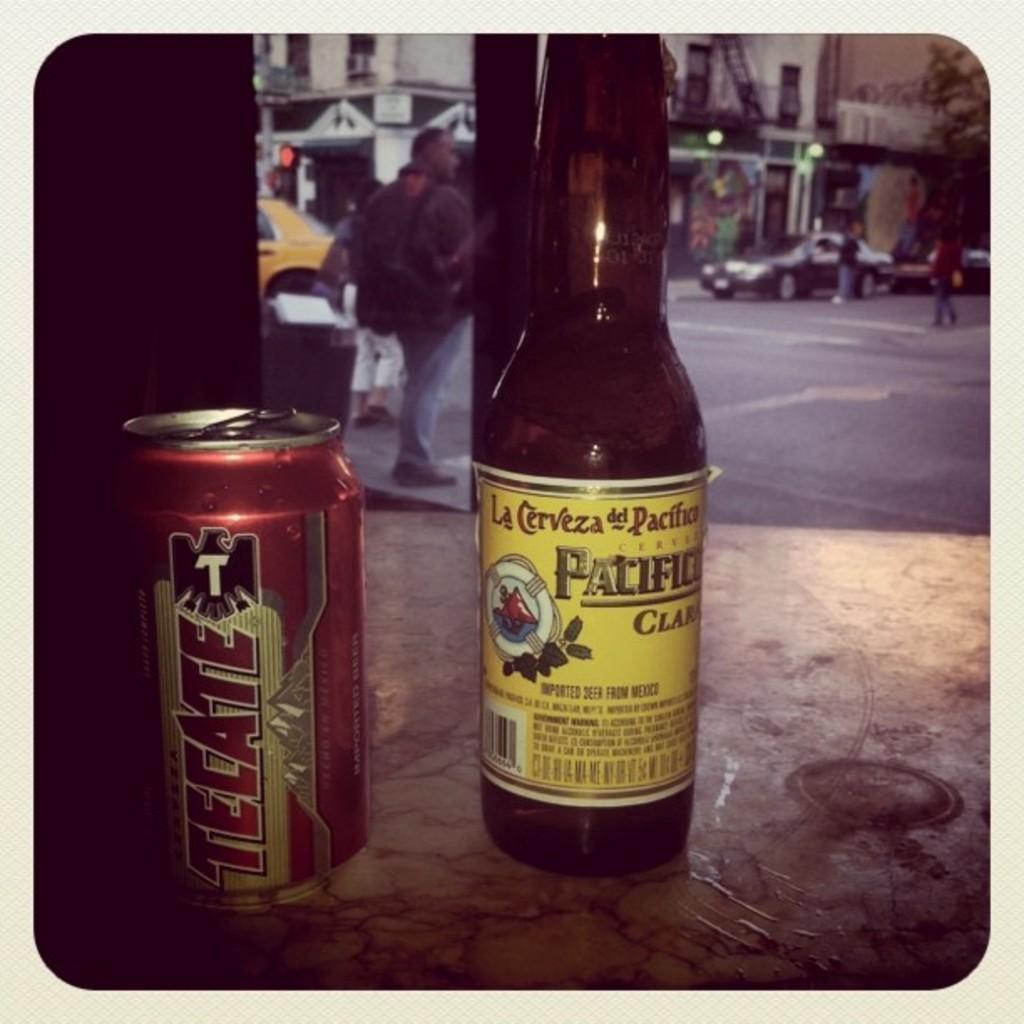What is the main object in the center of the image? There is a bottle at the center of the image. What other object can be seen on the left side of the image? There is a juice tin at the left side of the image. Can you describe the beginner's progress at the seashore in the image? There is no reference to a beginner or a seashore in the image; it only features a bottle and a juice tin. 